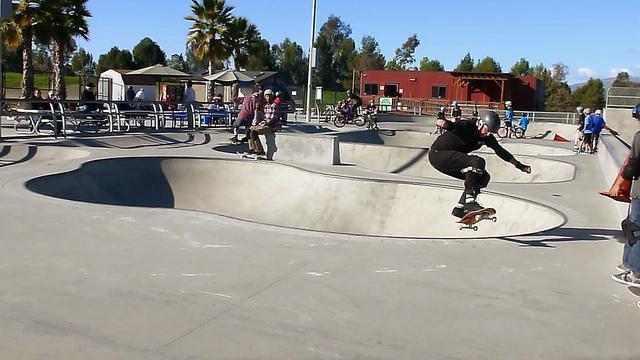Where are the skaters located?
Choose the correct response and explain in the format: 'Answer: answer
Rationale: rationale.'
Options: Street, store, park, mall. Answer: park.
Rationale: The skaters are at an outdoor skate park. 